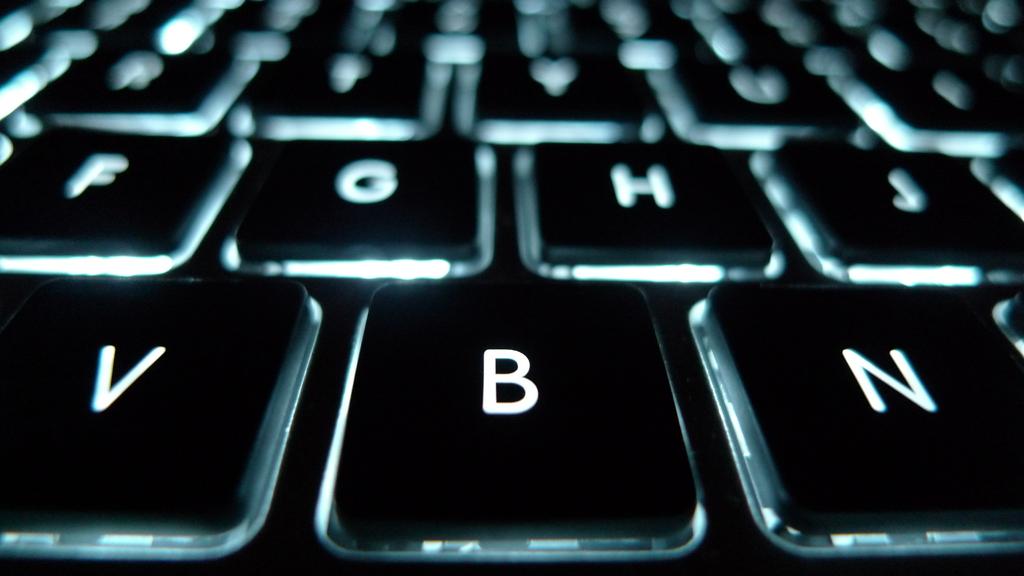What key is between v and n?
Offer a very short reply. B. 